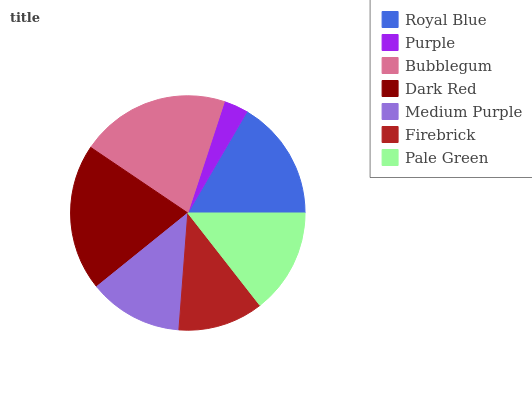Is Purple the minimum?
Answer yes or no. Yes. Is Bubblegum the maximum?
Answer yes or no. Yes. Is Bubblegum the minimum?
Answer yes or no. No. Is Purple the maximum?
Answer yes or no. No. Is Bubblegum greater than Purple?
Answer yes or no. Yes. Is Purple less than Bubblegum?
Answer yes or no. Yes. Is Purple greater than Bubblegum?
Answer yes or no. No. Is Bubblegum less than Purple?
Answer yes or no. No. Is Pale Green the high median?
Answer yes or no. Yes. Is Pale Green the low median?
Answer yes or no. Yes. Is Royal Blue the high median?
Answer yes or no. No. Is Medium Purple the low median?
Answer yes or no. No. 